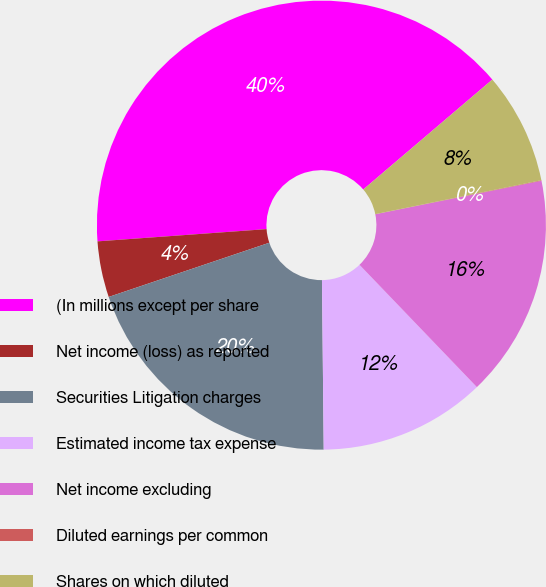<chart> <loc_0><loc_0><loc_500><loc_500><pie_chart><fcel>(In millions except per share<fcel>Net income (loss) as reported<fcel>Securities Litigation charges<fcel>Estimated income tax expense<fcel>Net income excluding<fcel>Diluted earnings per common<fcel>Shares on which diluted<nl><fcel>39.92%<fcel>4.03%<fcel>19.98%<fcel>12.01%<fcel>15.99%<fcel>0.04%<fcel>8.02%<nl></chart> 